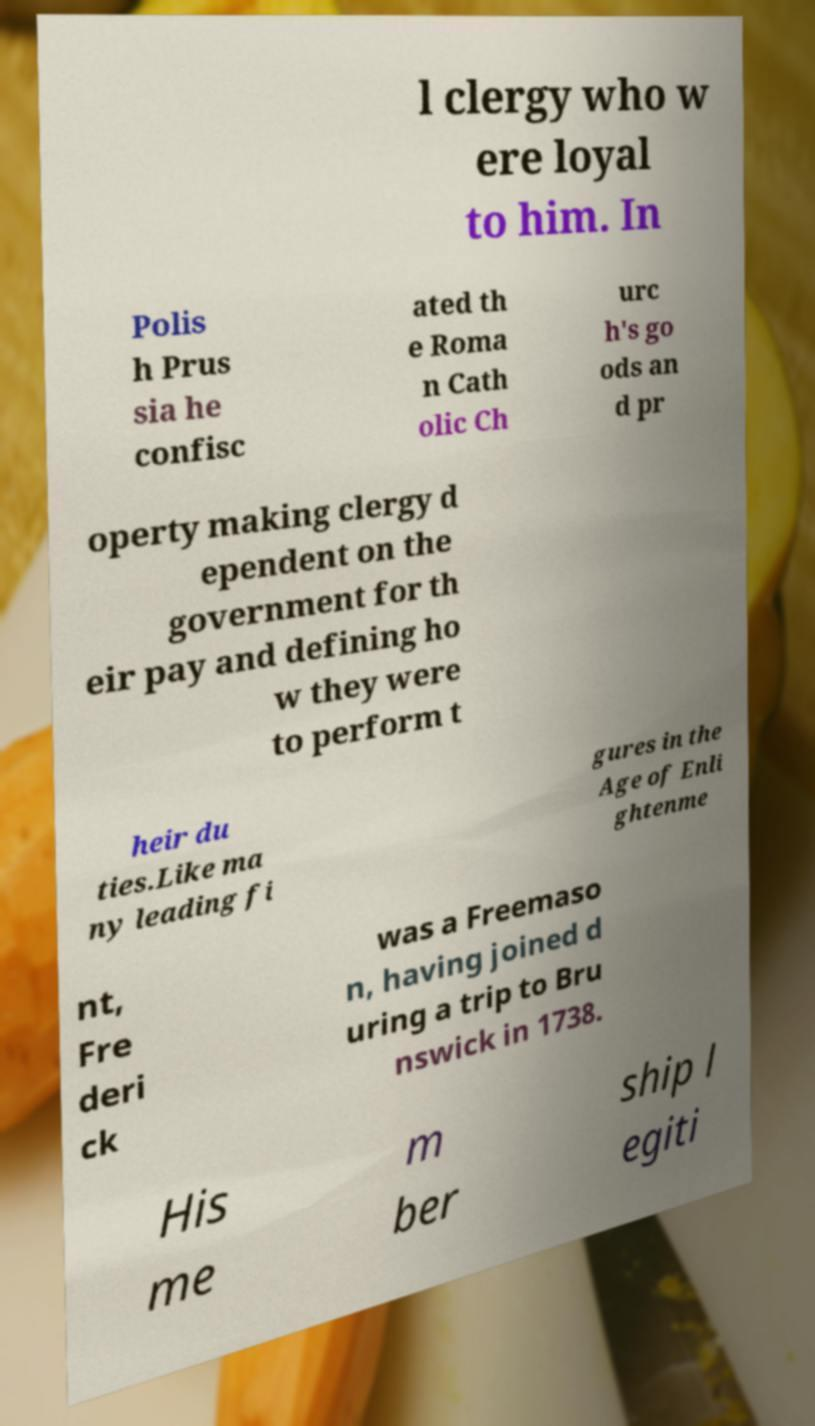Can you read and provide the text displayed in the image?This photo seems to have some interesting text. Can you extract and type it out for me? l clergy who w ere loyal to him. In Polis h Prus sia he confisc ated th e Roma n Cath olic Ch urc h's go ods an d pr operty making clergy d ependent on the government for th eir pay and defining ho w they were to perform t heir du ties.Like ma ny leading fi gures in the Age of Enli ghtenme nt, Fre deri ck was a Freemaso n, having joined d uring a trip to Bru nswick in 1738. His me m ber ship l egiti 